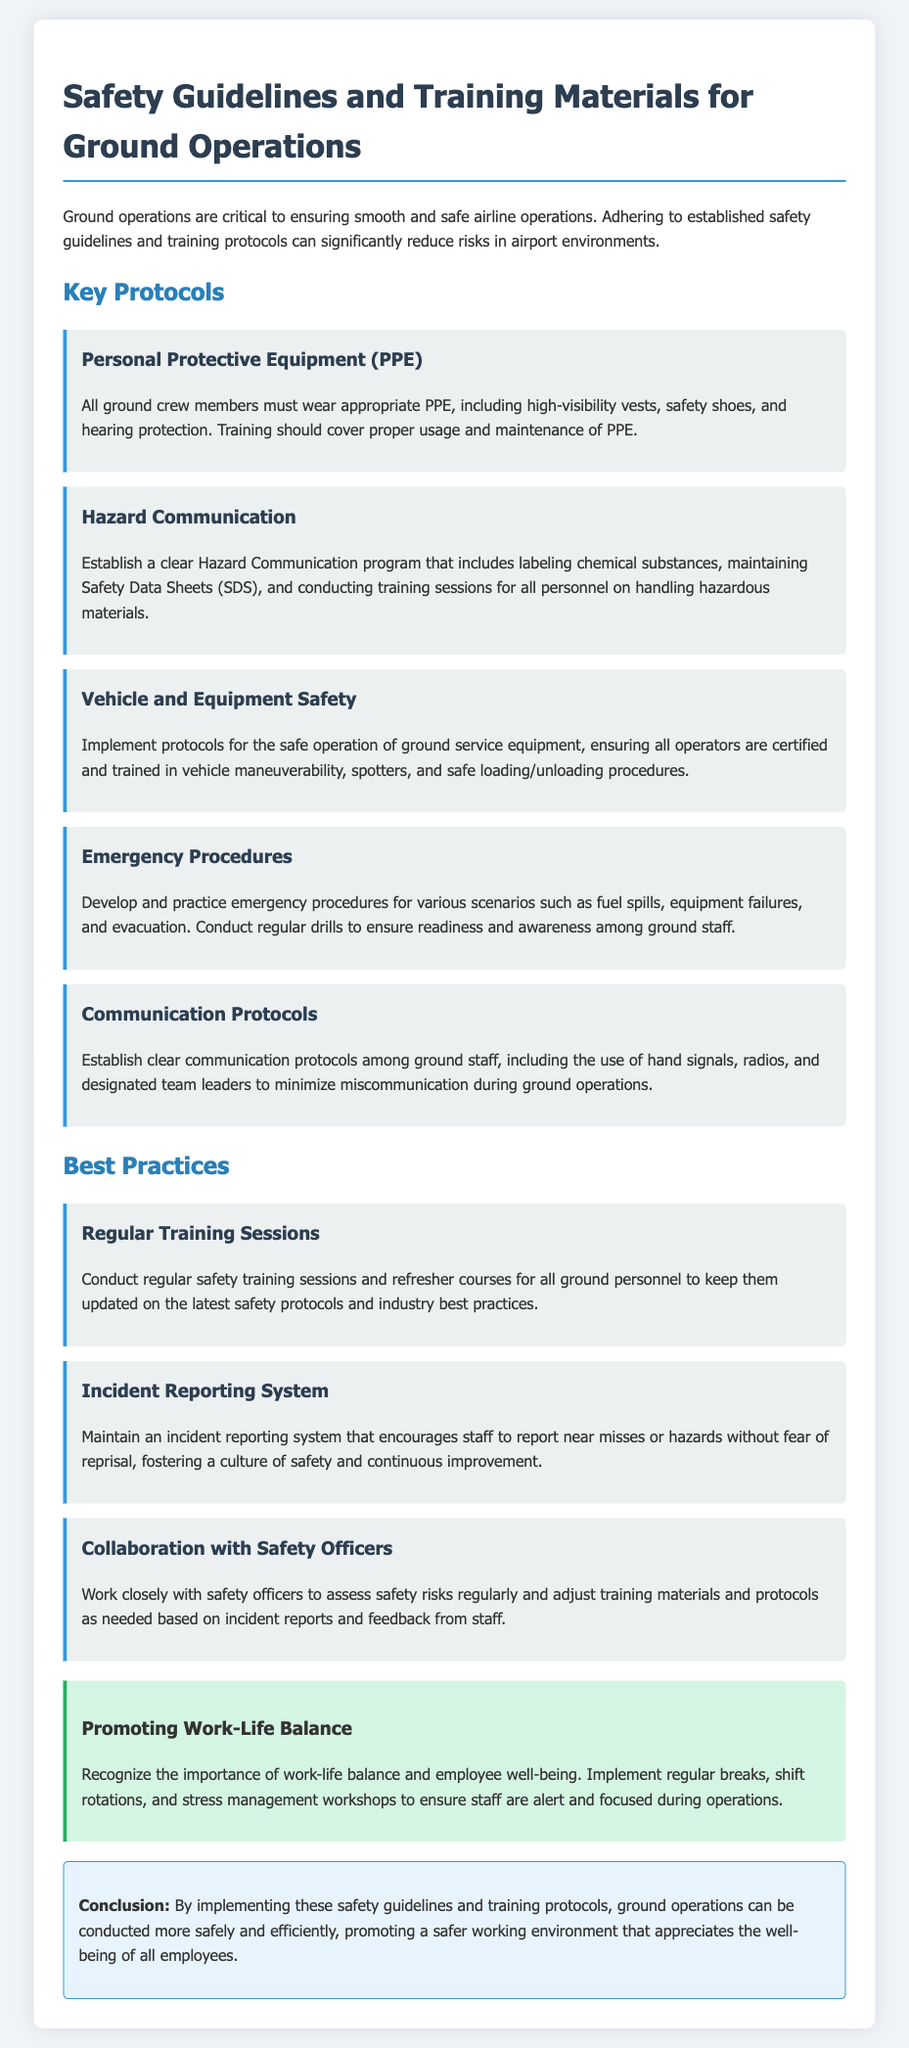What are the key protocols focused on in the document? The document outlines several key protocols necessary for ground operations safety, including Personal Protective Equipment, Hazard Communication, Vehicle and Equipment Safety, Emergency Procedures, and Communication Protocols.
Answer: Personal Protective Equipment, Hazard Communication, Vehicle and Equipment Safety, Emergency Procedures, Communication Protocols What does PPE stand for? The acronym PPE is defined in the section on Personal Protective Equipment.
Answer: Personal Protective Equipment How often should safety training sessions be conducted? The document states that regular safety training sessions should be conducted for all ground personnel without specifying an exact frequency, implying that they should be ongoing and updated regularly.
Answer: Regularly What item is specifically mentioned to encourage staff in the incident reporting system? The document highlights that the incident reporting system should encourage staff to report hazards without fear of reprisal.
Answer: Without fear of reprisal What is a suggested emergency procedure practice mentioned in the document? The document mentions that developing and practicing emergency procedures for various scenarios is important, along with conducting regular drills.
Answer: Regular drills What best practice involves working with safety officers? The document suggests collaborating with safety officers to assess safety risks and adjust protocols based on feedback.
Answer: Collaboration with Safety Officers What color is used for the work-life balance section? The work-life balance section background is described as green, specifically a light shade to promote well-being.
Answer: Green What is emphasized in the work-life balance section? The document emphasizes the importance of recognizing and promoting work-life balance along with employee well-being through various practices.
Answer: Employee well-being 